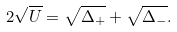Convert formula to latex. <formula><loc_0><loc_0><loc_500><loc_500>2 \sqrt { U } = \sqrt { \Delta _ { + } } + \sqrt { \Delta _ { - } } .</formula> 